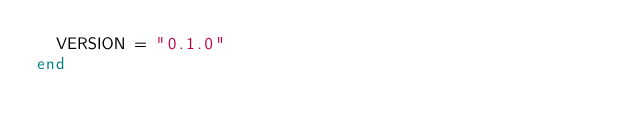<code> <loc_0><loc_0><loc_500><loc_500><_Crystal_>  VERSION = "0.1.0"
end
</code> 